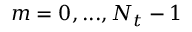Convert formula to latex. <formula><loc_0><loc_0><loc_500><loc_500>m = 0 , \dots , N _ { t } - 1</formula> 